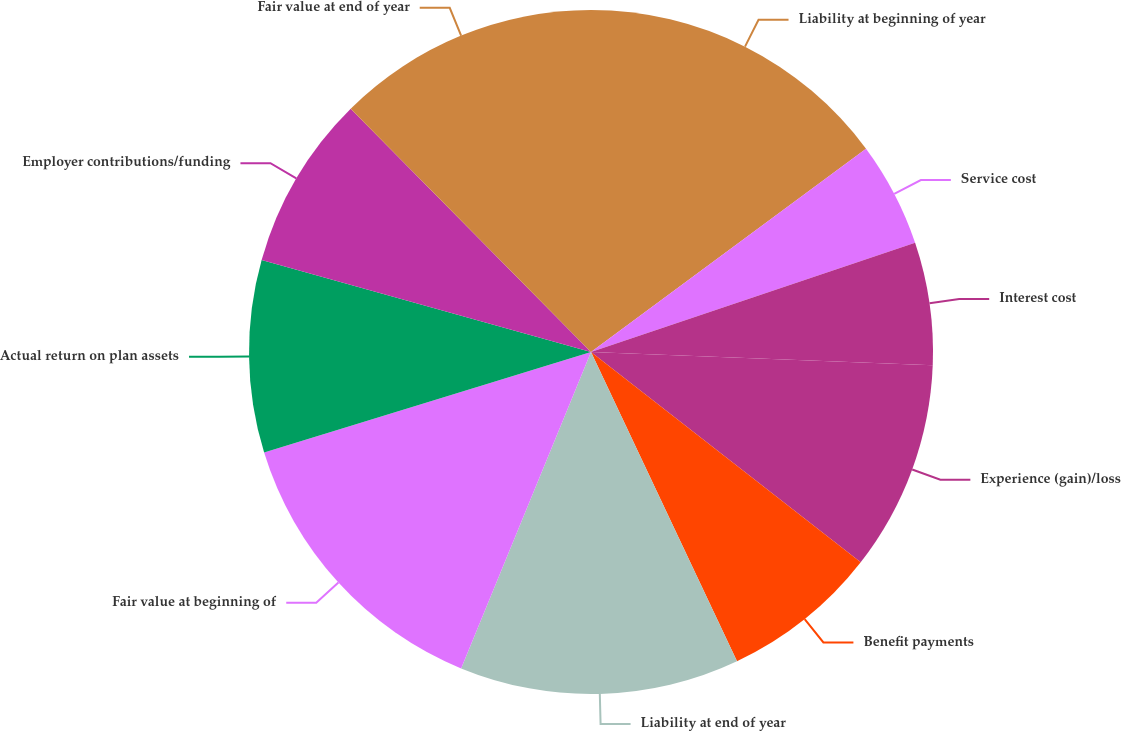<chart> <loc_0><loc_0><loc_500><loc_500><pie_chart><fcel>Liability at beginning of year<fcel>Service cost<fcel>Interest cost<fcel>Experience (gain)/loss<fcel>Benefit payments<fcel>Liability at end of year<fcel>Fair value at beginning of<fcel>Actual return on plan assets<fcel>Employer contributions/funding<fcel>Fair value at end of year<nl><fcel>14.87%<fcel>4.96%<fcel>5.79%<fcel>9.92%<fcel>7.44%<fcel>13.22%<fcel>14.05%<fcel>9.09%<fcel>8.26%<fcel>12.4%<nl></chart> 